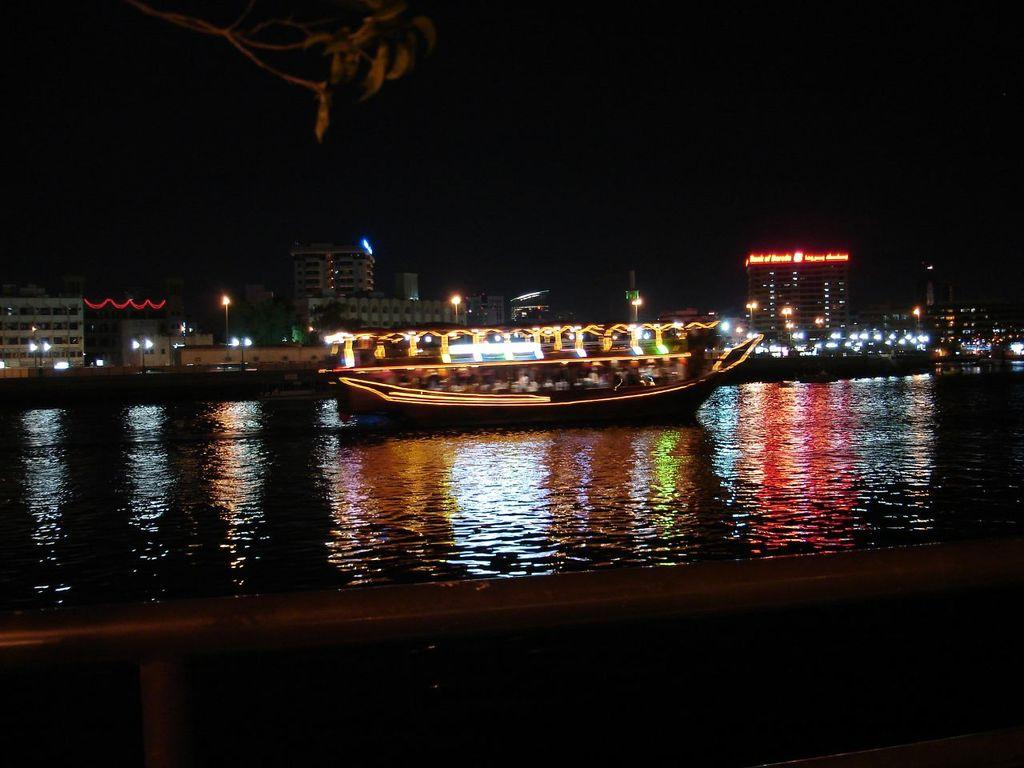What is the main subject of the image? The main subject of the image is a boat. Where is the boat located? The boat is on the water. What can be seen in the background of the image? In the background of the image, there are buildings, lights, poles and boards, and a tree. What is visible at the top of the image? The sky is visible at the top of the image. Can you read the letter that the crow is holding in the image? There is no letter or crow present in the image. How can we help the person in the boat in the image? There is no indication in the image that the person in the boat needs help, and we cannot interact with the image. 